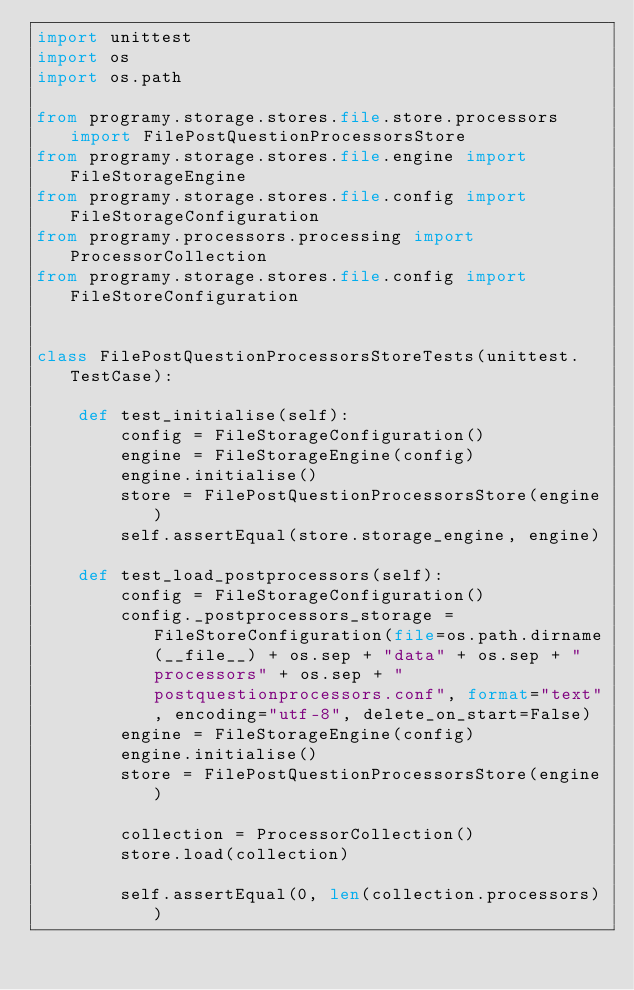Convert code to text. <code><loc_0><loc_0><loc_500><loc_500><_Python_>import unittest
import os
import os.path

from programy.storage.stores.file.store.processors import FilePostQuestionProcessorsStore
from programy.storage.stores.file.engine import FileStorageEngine
from programy.storage.stores.file.config import FileStorageConfiguration
from programy.processors.processing import ProcessorCollection
from programy.storage.stores.file.config import FileStoreConfiguration


class FilePostQuestionProcessorsStoreTests(unittest.TestCase):

    def test_initialise(self):
        config = FileStorageConfiguration()
        engine = FileStorageEngine(config)
        engine.initialise()
        store = FilePostQuestionProcessorsStore(engine)
        self.assertEqual(store.storage_engine, engine)

    def test_load_postprocessors(self):
        config = FileStorageConfiguration()
        config._postprocessors_storage = FileStoreConfiguration(file=os.path.dirname(__file__) + os.sep + "data" + os.sep + "processors" + os.sep + "postquestionprocessors.conf", format="text", encoding="utf-8", delete_on_start=False)
        engine = FileStorageEngine(config)
        engine.initialise()
        store = FilePostQuestionProcessorsStore(engine)

        collection = ProcessorCollection()
        store.load(collection)

        self.assertEqual(0, len(collection.processors))
</code> 